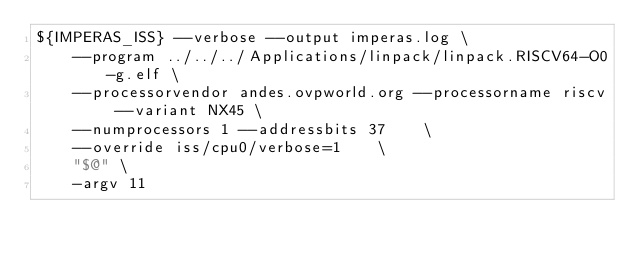Convert code to text. <code><loc_0><loc_0><loc_500><loc_500><_Bash_>${IMPERAS_ISS} --verbose --output imperas.log \
    --program ../../../Applications/linpack/linpack.RISCV64-O0-g.elf \
    --processorvendor andes.ovpworld.org --processorname riscv --variant NX45 \
    --numprocessors 1 --addressbits 37    \
    --override iss/cpu0/verbose=1    \
    "$@" \
    -argv 11

</code> 